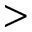<formula> <loc_0><loc_0><loc_500><loc_500>></formula> 